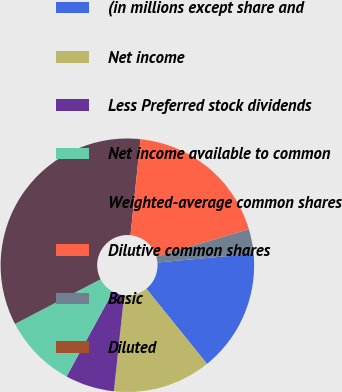Convert chart. <chart><loc_0><loc_0><loc_500><loc_500><pie_chart><fcel>(in millions except share and<fcel>Net income<fcel>Less Preferred stock dividends<fcel>Net income available to common<fcel>Weighted-average common shares<fcel>Dilutive common shares<fcel>Basic<fcel>Diluted<nl><fcel>15.64%<fcel>12.51%<fcel>6.26%<fcel>9.38%<fcel>34.31%<fcel>18.77%<fcel>3.13%<fcel>0.0%<nl></chart> 